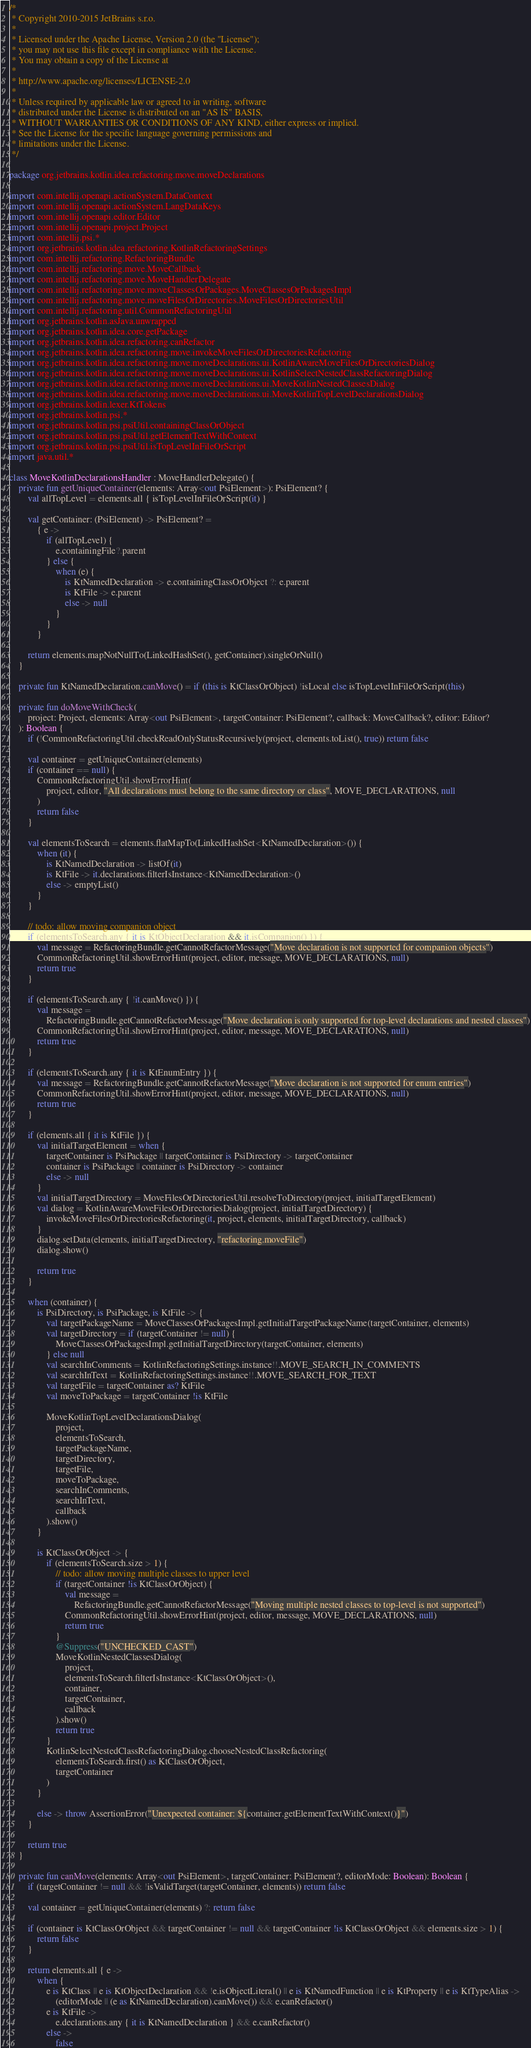Convert code to text. <code><loc_0><loc_0><loc_500><loc_500><_Kotlin_>/*
 * Copyright 2010-2015 JetBrains s.r.o.
 *
 * Licensed under the Apache License, Version 2.0 (the "License");
 * you may not use this file except in compliance with the License.
 * You may obtain a copy of the License at
 *
 * http://www.apache.org/licenses/LICENSE-2.0
 *
 * Unless required by applicable law or agreed to in writing, software
 * distributed under the License is distributed on an "AS IS" BASIS,
 * WITHOUT WARRANTIES OR CONDITIONS OF ANY KIND, either express or implied.
 * See the License for the specific language governing permissions and
 * limitations under the License.
 */

package org.jetbrains.kotlin.idea.refactoring.move.moveDeclarations

import com.intellij.openapi.actionSystem.DataContext
import com.intellij.openapi.actionSystem.LangDataKeys
import com.intellij.openapi.editor.Editor
import com.intellij.openapi.project.Project
import com.intellij.psi.*
import org.jetbrains.kotlin.idea.refactoring.KotlinRefactoringSettings
import com.intellij.refactoring.RefactoringBundle
import com.intellij.refactoring.move.MoveCallback
import com.intellij.refactoring.move.MoveHandlerDelegate
import com.intellij.refactoring.move.moveClassesOrPackages.MoveClassesOrPackagesImpl
import com.intellij.refactoring.move.moveFilesOrDirectories.MoveFilesOrDirectoriesUtil
import com.intellij.refactoring.util.CommonRefactoringUtil
import org.jetbrains.kotlin.asJava.unwrapped
import org.jetbrains.kotlin.idea.core.getPackage
import org.jetbrains.kotlin.idea.refactoring.canRefactor
import org.jetbrains.kotlin.idea.refactoring.move.invokeMoveFilesOrDirectoriesRefactoring
import org.jetbrains.kotlin.idea.refactoring.move.moveDeclarations.ui.KotlinAwareMoveFilesOrDirectoriesDialog
import org.jetbrains.kotlin.idea.refactoring.move.moveDeclarations.ui.KotlinSelectNestedClassRefactoringDialog
import org.jetbrains.kotlin.idea.refactoring.move.moveDeclarations.ui.MoveKotlinNestedClassesDialog
import org.jetbrains.kotlin.idea.refactoring.move.moveDeclarations.ui.MoveKotlinTopLevelDeclarationsDialog
import org.jetbrains.kotlin.lexer.KtTokens
import org.jetbrains.kotlin.psi.*
import org.jetbrains.kotlin.psi.psiUtil.containingClassOrObject
import org.jetbrains.kotlin.psi.psiUtil.getElementTextWithContext
import org.jetbrains.kotlin.psi.psiUtil.isTopLevelInFileOrScript
import java.util.*

class MoveKotlinDeclarationsHandler : MoveHandlerDelegate() {
    private fun getUniqueContainer(elements: Array<out PsiElement>): PsiElement? {
        val allTopLevel = elements.all { isTopLevelInFileOrScript(it) }

        val getContainer: (PsiElement) -> PsiElement? =
            { e ->
                if (allTopLevel) {
                    e.containingFile?.parent
                } else {
                    when (e) {
                        is KtNamedDeclaration -> e.containingClassOrObject ?: e.parent
                        is KtFile -> e.parent
                        else -> null
                    }
                }
            }

        return elements.mapNotNullTo(LinkedHashSet(), getContainer).singleOrNull()
    }

    private fun KtNamedDeclaration.canMove() = if (this is KtClassOrObject) !isLocal else isTopLevelInFileOrScript(this)

    private fun doMoveWithCheck(
        project: Project, elements: Array<out PsiElement>, targetContainer: PsiElement?, callback: MoveCallback?, editor: Editor?
    ): Boolean {
        if (!CommonRefactoringUtil.checkReadOnlyStatusRecursively(project, elements.toList(), true)) return false

        val container = getUniqueContainer(elements)
        if (container == null) {
            CommonRefactoringUtil.showErrorHint(
                project, editor, "All declarations must belong to the same directory or class", MOVE_DECLARATIONS, null
            )
            return false
        }

        val elementsToSearch = elements.flatMapTo(LinkedHashSet<KtNamedDeclaration>()) {
            when (it) {
                is KtNamedDeclaration -> listOf(it)
                is KtFile -> it.declarations.filterIsInstance<KtNamedDeclaration>()
                else -> emptyList()
            }
        }

        // todo: allow moving companion object
        if (elementsToSearch.any { it is KtObjectDeclaration && it.isCompanion() }) {
            val message = RefactoringBundle.getCannotRefactorMessage("Move declaration is not supported for companion objects")
            CommonRefactoringUtil.showErrorHint(project, editor, message, MOVE_DECLARATIONS, null)
            return true
        }

        if (elementsToSearch.any { !it.canMove() }) {
            val message =
                RefactoringBundle.getCannotRefactorMessage("Move declaration is only supported for top-level declarations and nested classes")
            CommonRefactoringUtil.showErrorHint(project, editor, message, MOVE_DECLARATIONS, null)
            return true
        }

        if (elementsToSearch.any { it is KtEnumEntry }) {
            val message = RefactoringBundle.getCannotRefactorMessage("Move declaration is not supported for enum entries")
            CommonRefactoringUtil.showErrorHint(project, editor, message, MOVE_DECLARATIONS, null)
            return true
        }

        if (elements.all { it is KtFile }) {
            val initialTargetElement = when {
                targetContainer is PsiPackage || targetContainer is PsiDirectory -> targetContainer
                container is PsiPackage || container is PsiDirectory -> container
                else -> null
            }
            val initialTargetDirectory = MoveFilesOrDirectoriesUtil.resolveToDirectory(project, initialTargetElement)
            val dialog = KotlinAwareMoveFilesOrDirectoriesDialog(project, initialTargetDirectory) {
                invokeMoveFilesOrDirectoriesRefactoring(it, project, elements, initialTargetDirectory, callback)
            }
            dialog.setData(elements, initialTargetDirectory, "refactoring.moveFile")
            dialog.show()

            return true
        }

        when (container) {
            is PsiDirectory, is PsiPackage, is KtFile -> {
                val targetPackageName = MoveClassesOrPackagesImpl.getInitialTargetPackageName(targetContainer, elements)
                val targetDirectory = if (targetContainer != null) {
                    MoveClassesOrPackagesImpl.getInitialTargetDirectory(targetContainer, elements)
                } else null
                val searchInComments = KotlinRefactoringSettings.instance!!.MOVE_SEARCH_IN_COMMENTS
                val searchInText = KotlinRefactoringSettings.instance!!.MOVE_SEARCH_FOR_TEXT
                val targetFile = targetContainer as? KtFile
                val moveToPackage = targetContainer !is KtFile

                MoveKotlinTopLevelDeclarationsDialog(
                    project,
                    elementsToSearch,
                    targetPackageName,
                    targetDirectory,
                    targetFile,
                    moveToPackage,
                    searchInComments,
                    searchInText,
                    callback
                ).show()
            }

            is KtClassOrObject -> {
                if (elementsToSearch.size > 1) {
                    // todo: allow moving multiple classes to upper level
                    if (targetContainer !is KtClassOrObject) {
                        val message =
                            RefactoringBundle.getCannotRefactorMessage("Moving multiple nested classes to top-level is not supported")
                        CommonRefactoringUtil.showErrorHint(project, editor, message, MOVE_DECLARATIONS, null)
                        return true
                    }
                    @Suppress("UNCHECKED_CAST")
                    MoveKotlinNestedClassesDialog(
                        project,
                        elementsToSearch.filterIsInstance<KtClassOrObject>(),
                        container,
                        targetContainer,
                        callback
                    ).show()
                    return true
                }
                KotlinSelectNestedClassRefactoringDialog.chooseNestedClassRefactoring(
                    elementsToSearch.first() as KtClassOrObject,
                    targetContainer
                )
            }

            else -> throw AssertionError("Unexpected container: ${container.getElementTextWithContext()}")
        }

        return true
    }

    private fun canMove(elements: Array<out PsiElement>, targetContainer: PsiElement?, editorMode: Boolean): Boolean {
        if (targetContainer != null && !isValidTarget(targetContainer, elements)) return false

        val container = getUniqueContainer(elements) ?: return false

        if (container is KtClassOrObject && targetContainer != null && targetContainer !is KtClassOrObject && elements.size > 1) {
            return false
        }

        return elements.all { e ->
            when {
                e is KtClass || e is KtObjectDeclaration && !e.isObjectLiteral() || e is KtNamedFunction || e is KtProperty || e is KtTypeAlias ->
                    (editorMode || (e as KtNamedDeclaration).canMove()) && e.canRefactor()
                e is KtFile ->
                    e.declarations.any { it is KtNamedDeclaration } && e.canRefactor()
                else ->
                    false</code> 